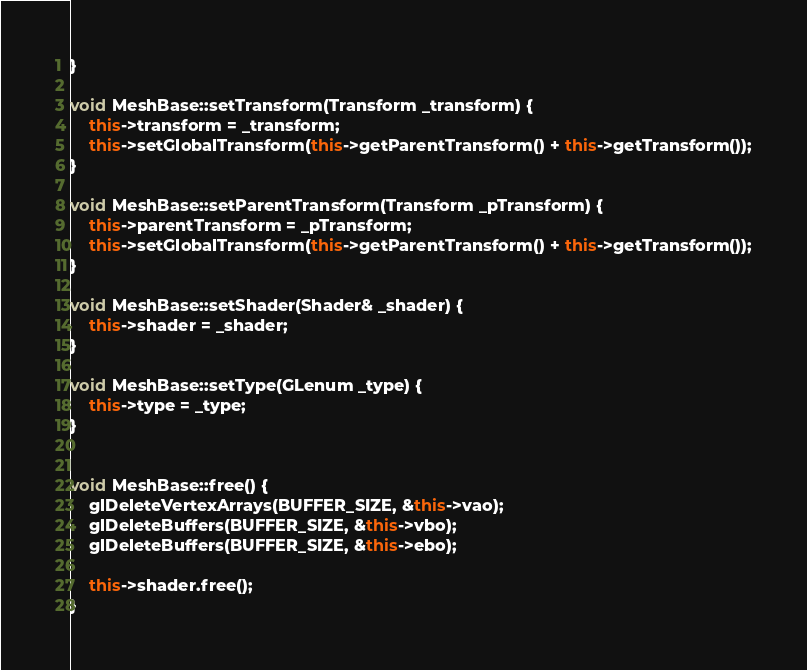<code> <loc_0><loc_0><loc_500><loc_500><_C++_>}

void MeshBase::setTransform(Transform _transform) {
	this->transform = _transform;
	this->setGlobalTransform(this->getParentTransform() + this->getTransform());
}

void MeshBase::setParentTransform(Transform _pTransform) {
	this->parentTransform = _pTransform;
	this->setGlobalTransform(this->getParentTransform() + this->getTransform());
}

void MeshBase::setShader(Shader& _shader) {
	this->shader = _shader;
}

void MeshBase::setType(GLenum _type) {
	this->type = _type;
}


void MeshBase::free() {
	glDeleteVertexArrays(BUFFER_SIZE, &this->vao);
	glDeleteBuffers(BUFFER_SIZE, &this->vbo);
	glDeleteBuffers(BUFFER_SIZE, &this->ebo);

	this->shader.free();
}
</code> 